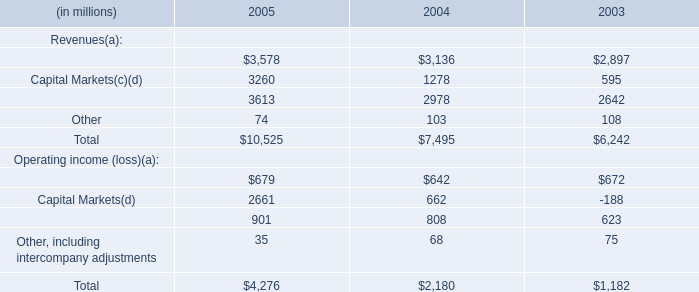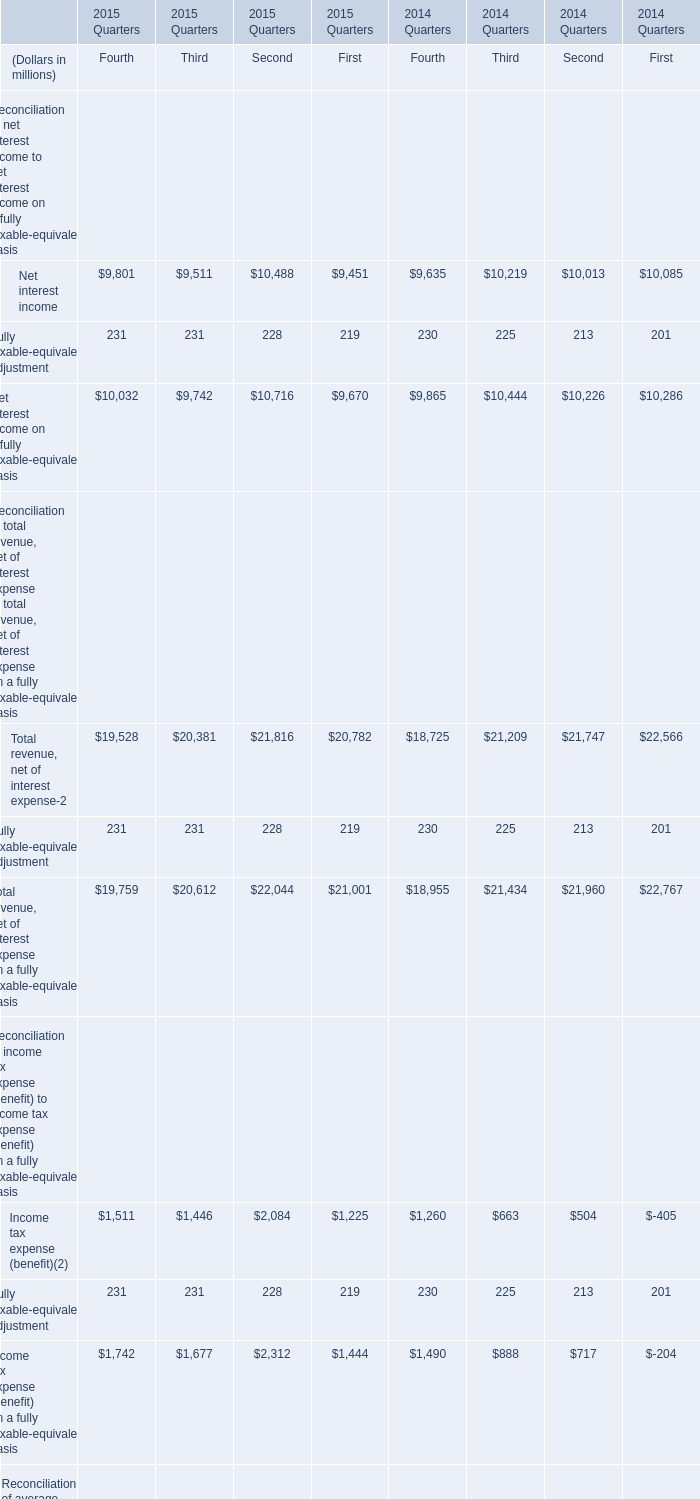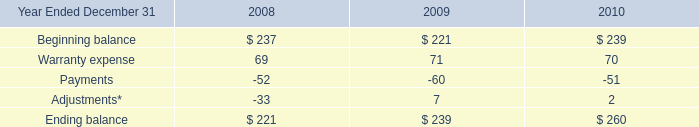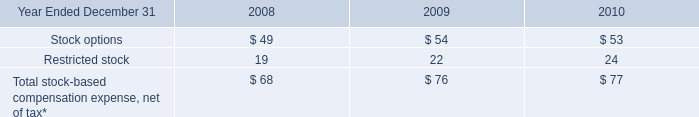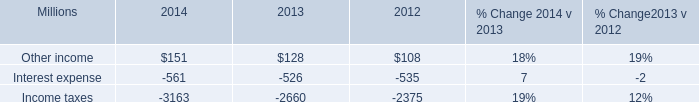depreciation was up how much in total for 2013 and 2012? 
Computations: (1% + 7%)
Answer: 0.08. 